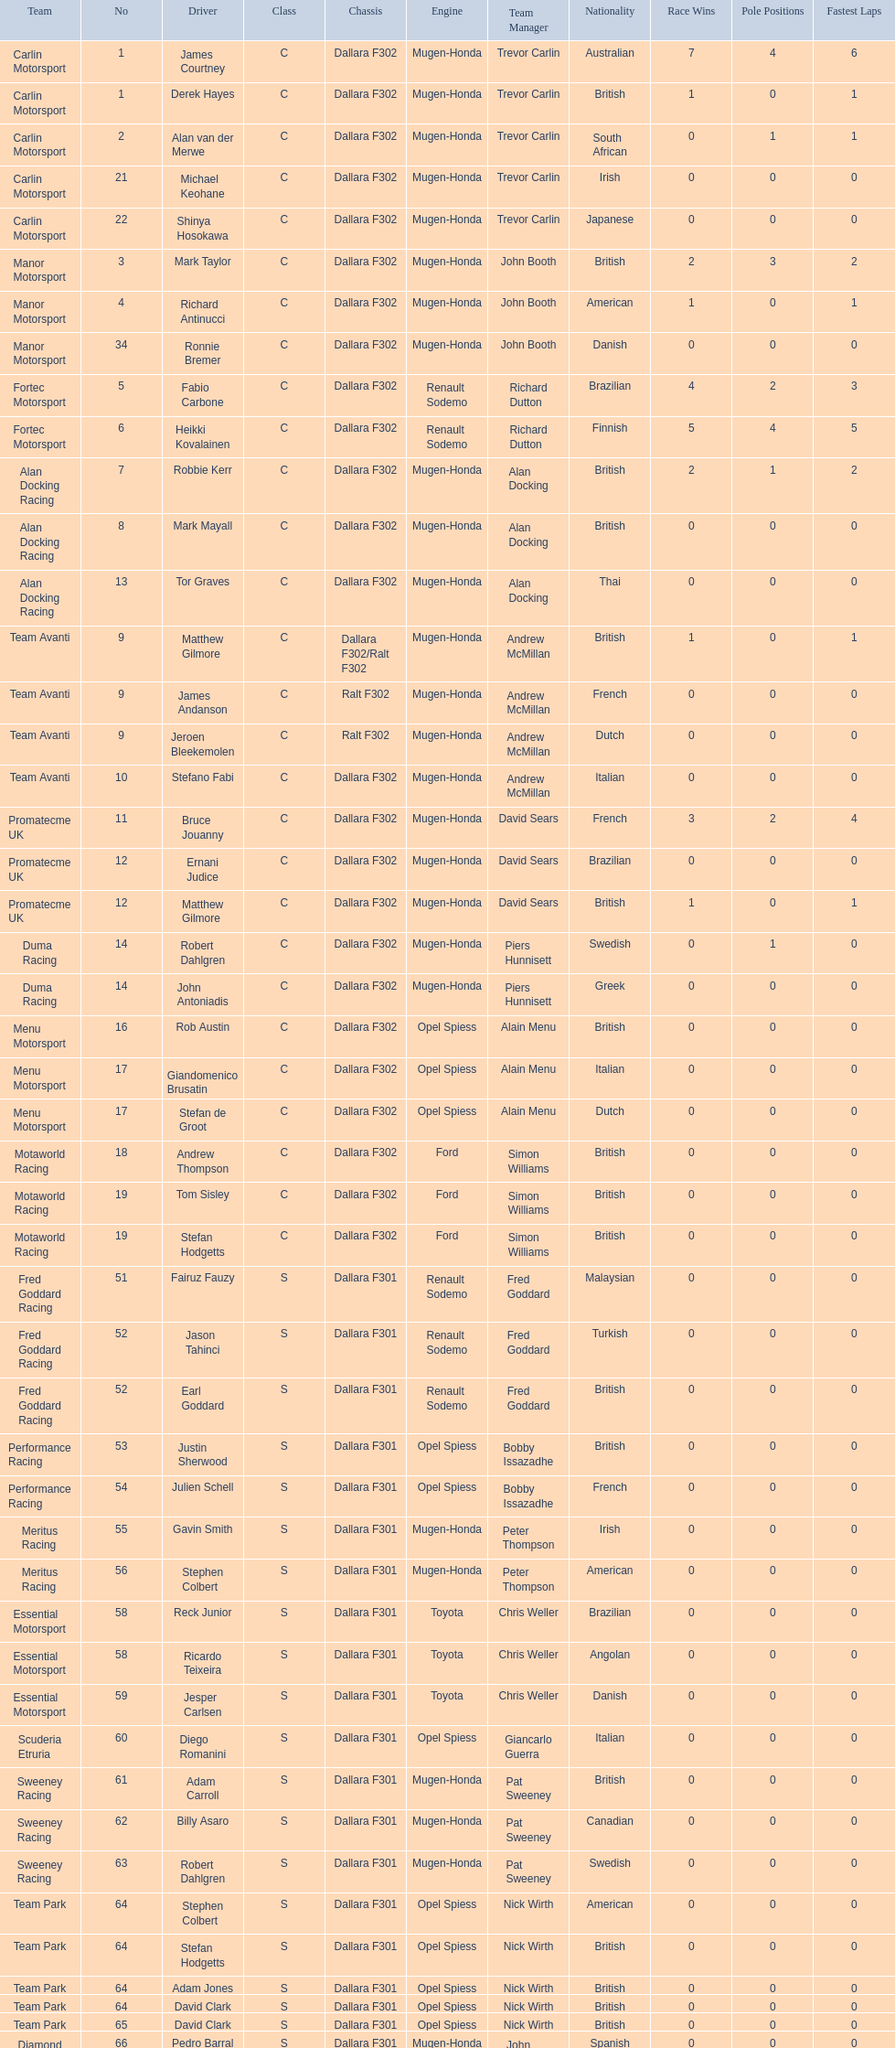Which engine was used the most by teams this season? Mugen-Honda. 